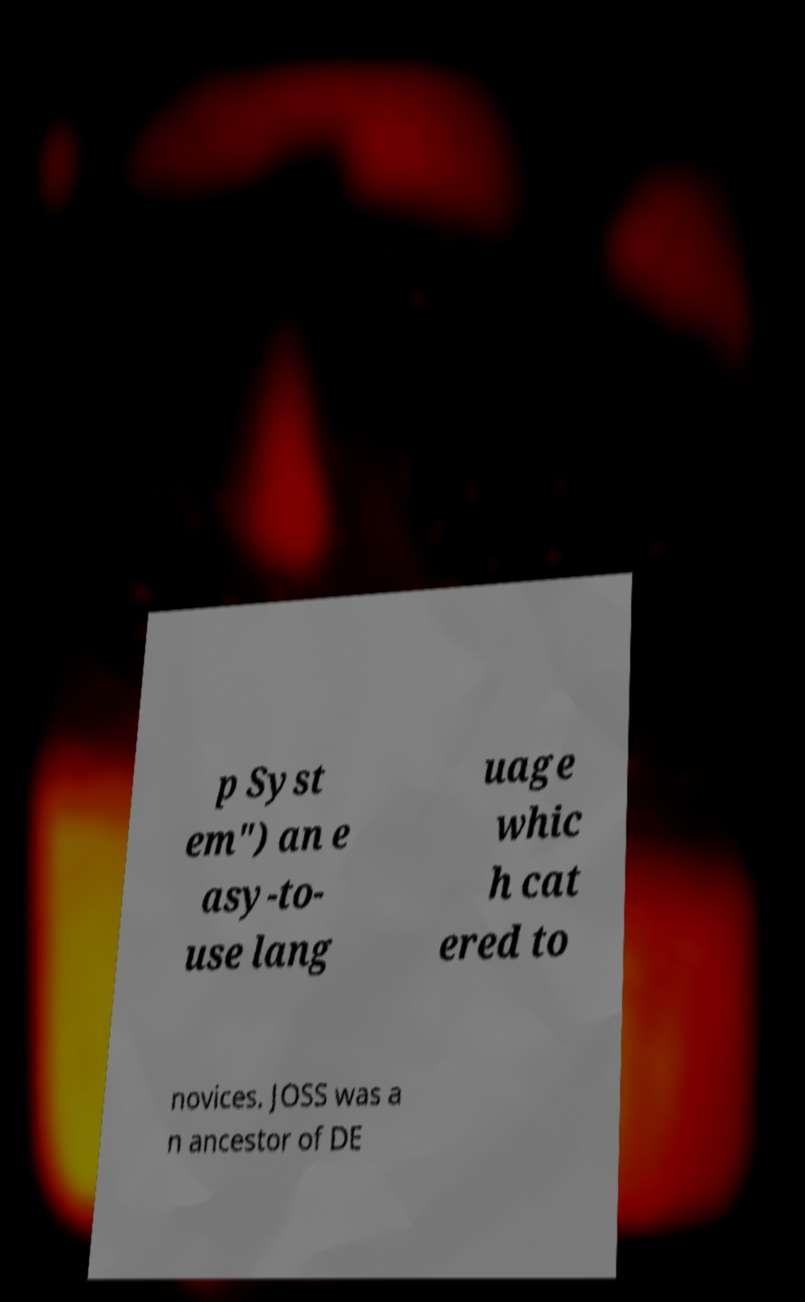Could you assist in decoding the text presented in this image and type it out clearly? p Syst em") an e asy-to- use lang uage whic h cat ered to novices. JOSS was a n ancestor of DE 